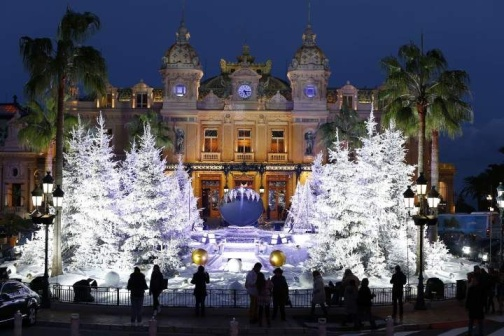Imagine if this scene was part of a magical realm. Describe the magical elements. In a magical realm, the building would be known as the Palace of Eternal Light, with its glow powered by enchanted crystals that change colors based on the emotions of those nearby. The fountain would grant wishes to those who dropped a token into its waters. The palm trees would whisper ancient secrets to those who cared to listen, their leaves shimmering with every word. The lights adorning the fountain would be fireflies that glow brighter with each happy thought around them. People would see visions of magical creatures like fairies and unicorns dancing in the reflections of the still water, turning the night into a spectacle of wonder and fantasy. 